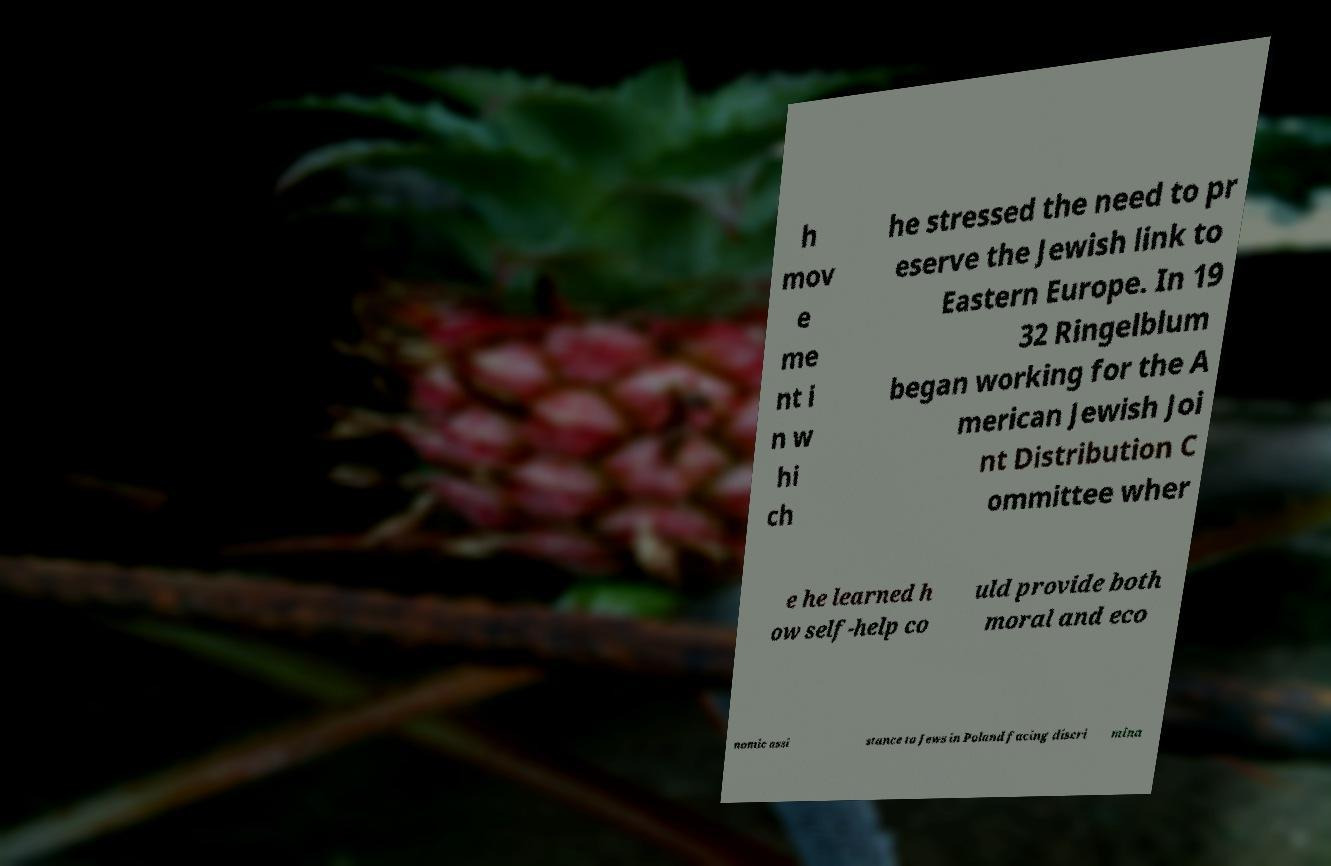Could you assist in decoding the text presented in this image and type it out clearly? h mov e me nt i n w hi ch he stressed the need to pr eserve the Jewish link to Eastern Europe. In 19 32 Ringelblum began working for the A merican Jewish Joi nt Distribution C ommittee wher e he learned h ow self-help co uld provide both moral and eco nomic assi stance to Jews in Poland facing discri mina 